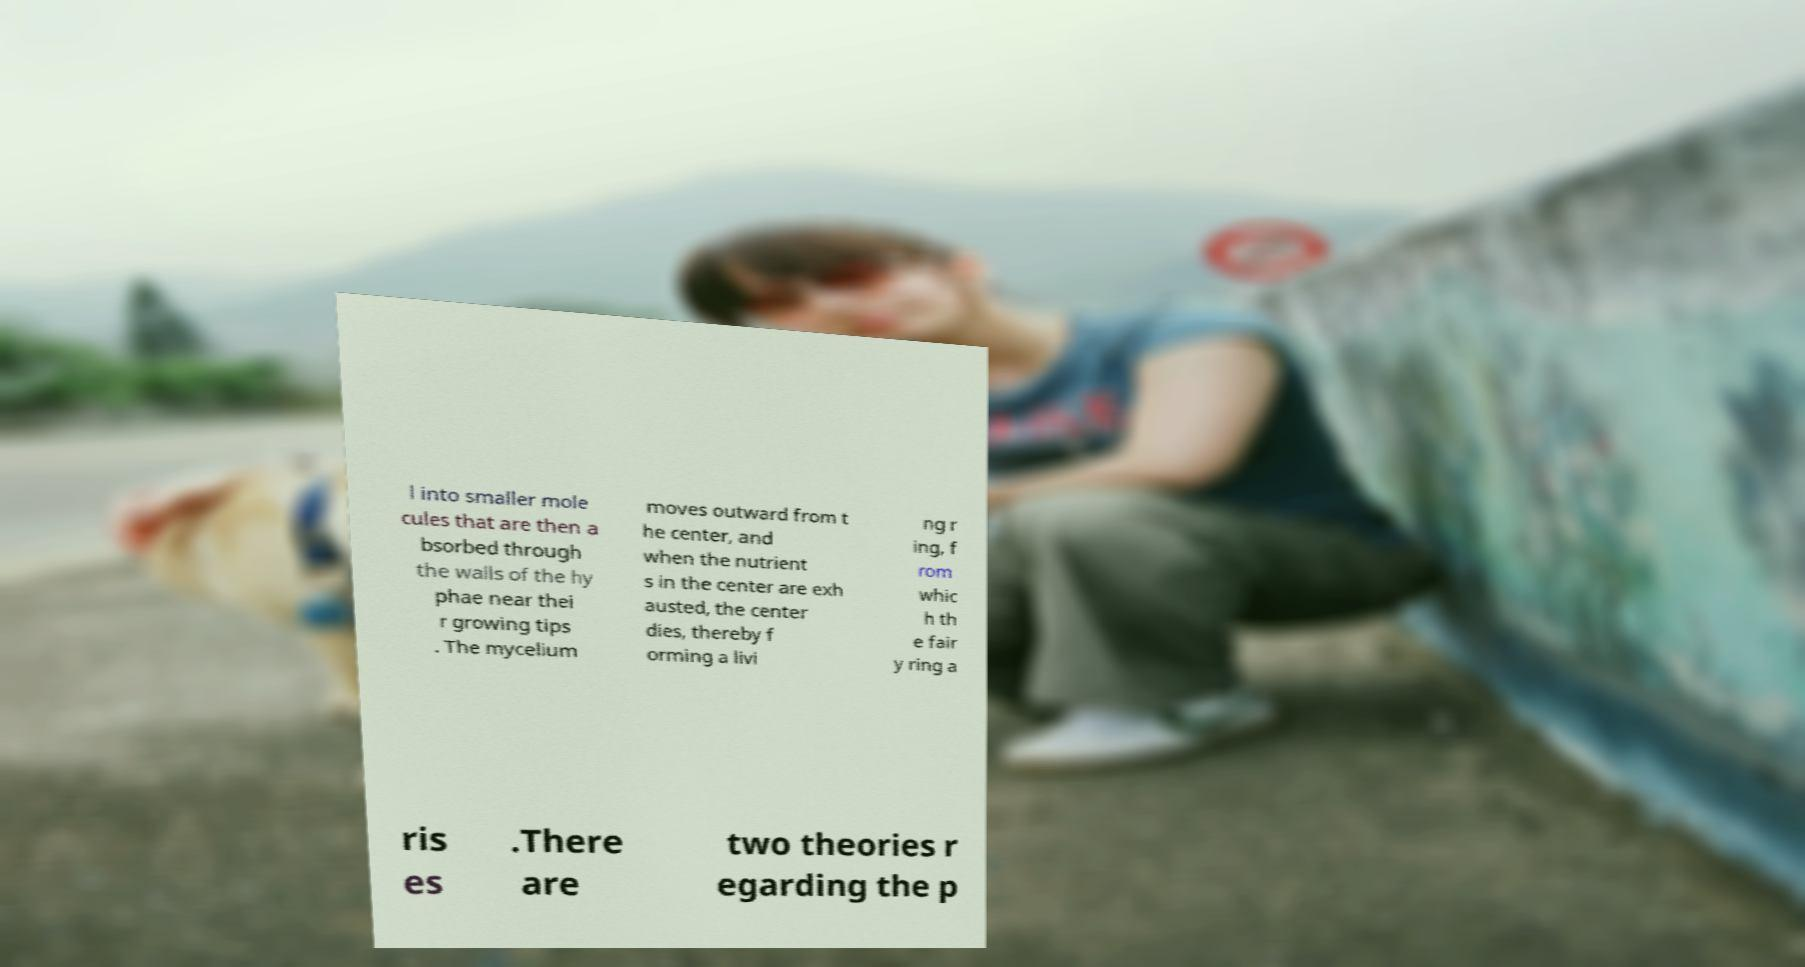What messages or text are displayed in this image? I need them in a readable, typed format. l into smaller mole cules that are then a bsorbed through the walls of the hy phae near thei r growing tips . The mycelium moves outward from t he center, and when the nutrient s in the center are exh austed, the center dies, thereby f orming a livi ng r ing, f rom whic h th e fair y ring a ris es .There are two theories r egarding the p 